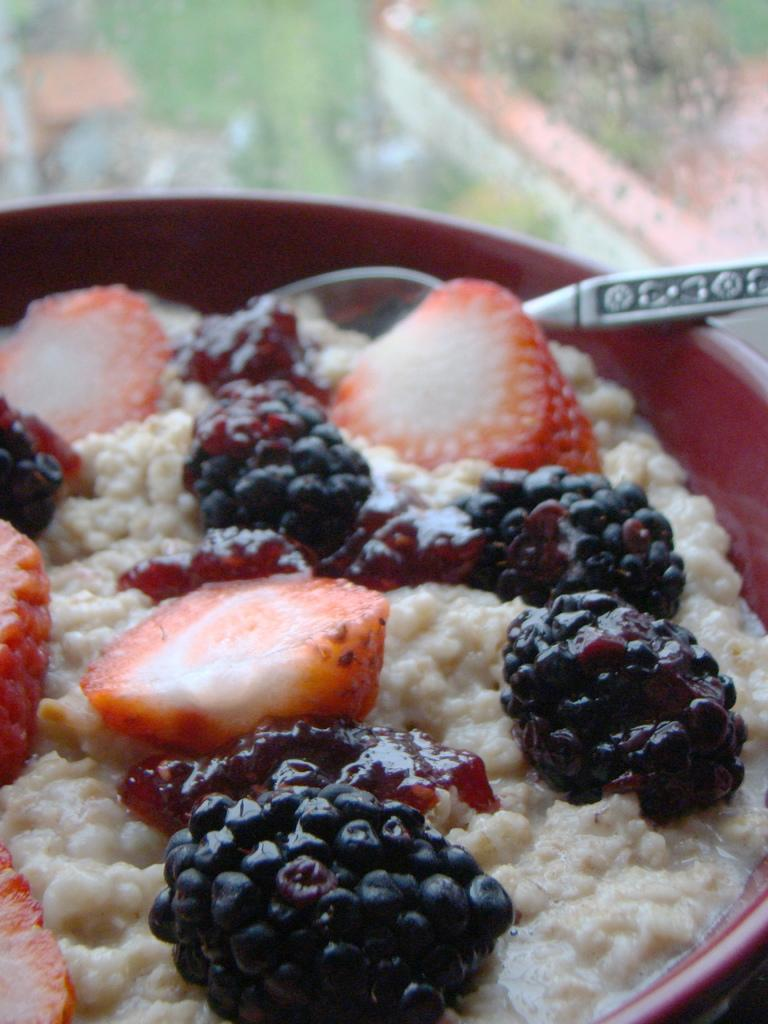What is present in the image that can be eaten? There is food in the image. What utensil is used with the food in the image? There is a spoon in the bowl. Can you describe the background of the image? The background of the image is blurry. What type of crown is being worn by the representative in the image? There is no representative or crown present in the image. Is there any smoke visible in the image? There is no smoke present in the image. 